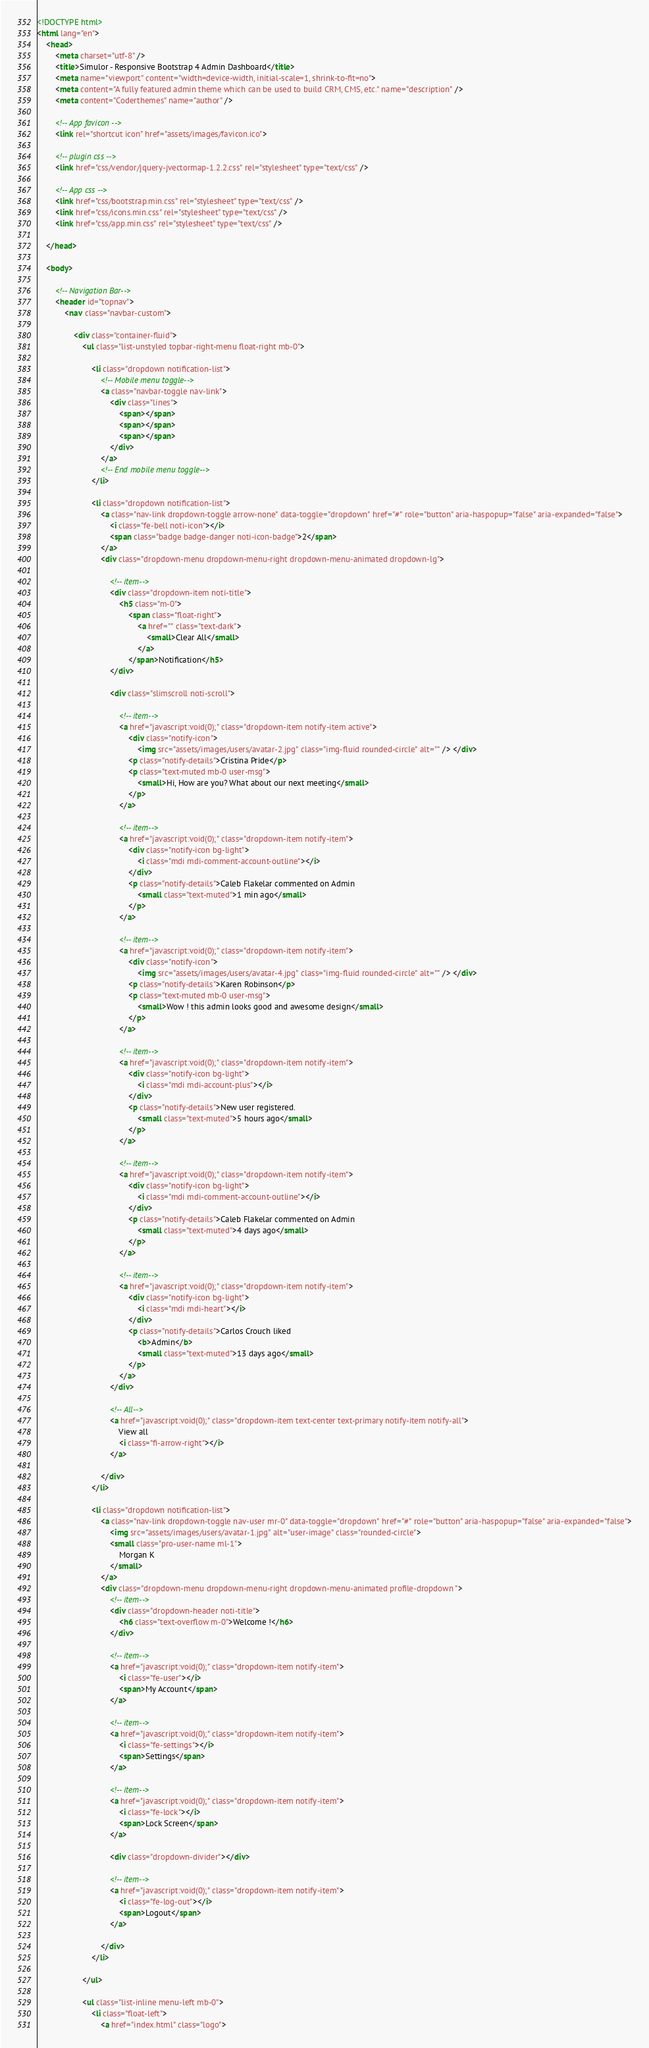<code> <loc_0><loc_0><loc_500><loc_500><_HTML_><!DOCTYPE html>
<html lang="en">
    <head>
        <meta charset="utf-8" />
        <title>Simulor - Responsive Bootstrap 4 Admin Dashboard</title>
        <meta name="viewport" content="width=device-width, initial-scale=1, shrink-to-fit=no">
        <meta content="A fully featured admin theme which can be used to build CRM, CMS, etc." name="description" />
        <meta content="Coderthemes" name="author" />

        <!-- App favicon -->
        <link rel="shortcut icon" href="assets/images/favicon.ico">

        <!-- plugin css -->
        <link href="css/vendor/jquery-jvectormap-1.2.2.css" rel="stylesheet" type="text/css" />

        <!-- App css -->
        <link href="css/bootstrap.min.css" rel="stylesheet" type="text/css" />
        <link href="css/icons.min.css" rel="stylesheet" type="text/css" />
        <link href="css/app.min.css" rel="stylesheet" type="text/css" />

    </head>

    <body>

        <!-- Navigation Bar-->
        <header id="topnav">
            <nav class="navbar-custom">

                <div class="container-fluid">
                    <ul class="list-unstyled topbar-right-menu float-right mb-0">

                        <li class="dropdown notification-list">
                            <!-- Mobile menu toggle-->
                            <a class="navbar-toggle nav-link">
                                <div class="lines">
                                    <span></span>
                                    <span></span>
                                    <span></span>
                                </div>
                            </a>
                            <!-- End mobile menu toggle-->
                        </li>

                        <li class="dropdown notification-list">
                            <a class="nav-link dropdown-toggle arrow-none" data-toggle="dropdown" href="#" role="button" aria-haspopup="false" aria-expanded="false">
                                <i class="fe-bell noti-icon"></i>
                                <span class="badge badge-danger noti-icon-badge">2</span>
                            </a>
                            <div class="dropdown-menu dropdown-menu-right dropdown-menu-animated dropdown-lg">

                                <!-- item-->
                                <div class="dropdown-item noti-title">
                                    <h5 class="m-0">
                                        <span class="float-right">
                                            <a href="" class="text-dark">
                                                <small>Clear All</small>
                                            </a>
                                        </span>Notification</h5>
                                </div>

                                <div class="slimscroll noti-scroll">

                                    <!-- item-->
                                    <a href="javascript:void(0);" class="dropdown-item notify-item active">
                                        <div class="notify-icon">
                                            <img src="assets/images/users/avatar-2.jpg" class="img-fluid rounded-circle" alt="" /> </div>
                                        <p class="notify-details">Cristina Pride</p>
                                        <p class="text-muted mb-0 user-msg">
                                            <small>Hi, How are you? What about our next meeting</small>
                                        </p>
                                    </a>

                                    <!-- item-->
                                    <a href="javascript:void(0);" class="dropdown-item notify-item">
                                        <div class="notify-icon bg-light">
                                            <i class="mdi mdi-comment-account-outline"></i>
                                        </div>
                                        <p class="notify-details">Caleb Flakelar commented on Admin
                                            <small class="text-muted">1 min ago</small>
                                        </p>
                                    </a>

                                    <!-- item-->
                                    <a href="javascript:void(0);" class="dropdown-item notify-item">
                                        <div class="notify-icon">
                                            <img src="assets/images/users/avatar-4.jpg" class="img-fluid rounded-circle" alt="" /> </div>
                                        <p class="notify-details">Karen Robinson</p>
                                        <p class="text-muted mb-0 user-msg">
                                            <small>Wow ! this admin looks good and awesome design</small>
                                        </p>
                                    </a>

                                    <!-- item-->
                                    <a href="javascript:void(0);" class="dropdown-item notify-item">
                                        <div class="notify-icon bg-light">
                                            <i class="mdi mdi-account-plus"></i>
                                        </div>
                                        <p class="notify-details">New user registered.
                                            <small class="text-muted">5 hours ago</small>
                                        </p>
                                    </a>

                                    <!-- item-->
                                    <a href="javascript:void(0);" class="dropdown-item notify-item">
                                        <div class="notify-icon bg-light">
                                            <i class="mdi mdi-comment-account-outline"></i>
                                        </div>
                                        <p class="notify-details">Caleb Flakelar commented on Admin
                                            <small class="text-muted">4 days ago</small>
                                        </p>
                                    </a>

                                    <!-- item-->
                                    <a href="javascript:void(0);" class="dropdown-item notify-item">
                                        <div class="notify-icon bg-light">
                                            <i class="mdi mdi-heart"></i>
                                        </div>
                                        <p class="notify-details">Carlos Crouch liked
                                            <b>Admin</b>
                                            <small class="text-muted">13 days ago</small>
                                        </p>
                                    </a>
                                </div>

                                <!-- All-->
                                <a href="javascript:void(0);" class="dropdown-item text-center text-primary notify-item notify-all">
                                    View all
                                    <i class="fi-arrow-right"></i>
                                </a>

                            </div>
                        </li>

                        <li class="dropdown notification-list">
                            <a class="nav-link dropdown-toggle nav-user mr-0" data-toggle="dropdown" href="#" role="button" aria-haspopup="false" aria-expanded="false">
                                <img src="assets/images/users/avatar-1.jpg" alt="user-image" class="rounded-circle">
                                <small class="pro-user-name ml-1">
                                    Morgan K
                                </small>
                            </a>
                            <div class="dropdown-menu dropdown-menu-right dropdown-menu-animated profile-dropdown ">
                                <!-- item-->
                                <div class="dropdown-header noti-title">
                                    <h6 class="text-overflow m-0">Welcome !</h6>
                                </div>

                                <!-- item-->
                                <a href="javascript:void(0);" class="dropdown-item notify-item">
                                    <i class="fe-user"></i>
                                    <span>My Account</span>
                                </a>

                                <!-- item-->
                                <a href="javascript:void(0);" class="dropdown-item notify-item">
                                    <i class="fe-settings"></i>
                                    <span>Settings</span>
                                </a>

                                <!-- item-->
                                <a href="javascript:void(0);" class="dropdown-item notify-item">
                                    <i class="fe-lock"></i>
                                    <span>Lock Screen</span>
                                </a>

                                <div class="dropdown-divider"></div>

                                <!-- item-->
                                <a href="javascript:void(0);" class="dropdown-item notify-item">
                                    <i class="fe-log-out"></i>
                                    <span>Logout</span>
                                </a>

                            </div>
                        </li>

                    </ul>

                    <ul class="list-inline menu-left mb-0">
                        <li class="float-left">
                            <a href="index.html" class="logo"></code> 